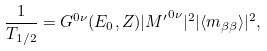<formula> <loc_0><loc_0><loc_500><loc_500>\frac { 1 } { T _ { 1 / 2 } } = G ^ { 0 \nu } ( E _ { 0 } , Z ) | { M ^ { \prime } } ^ { 0 \nu } | ^ { 2 } | \langle m _ { \beta \beta } \rangle | ^ { 2 } ,</formula> 